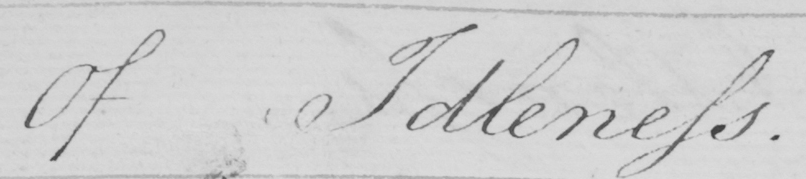What text is written in this handwritten line? Of Idleness 